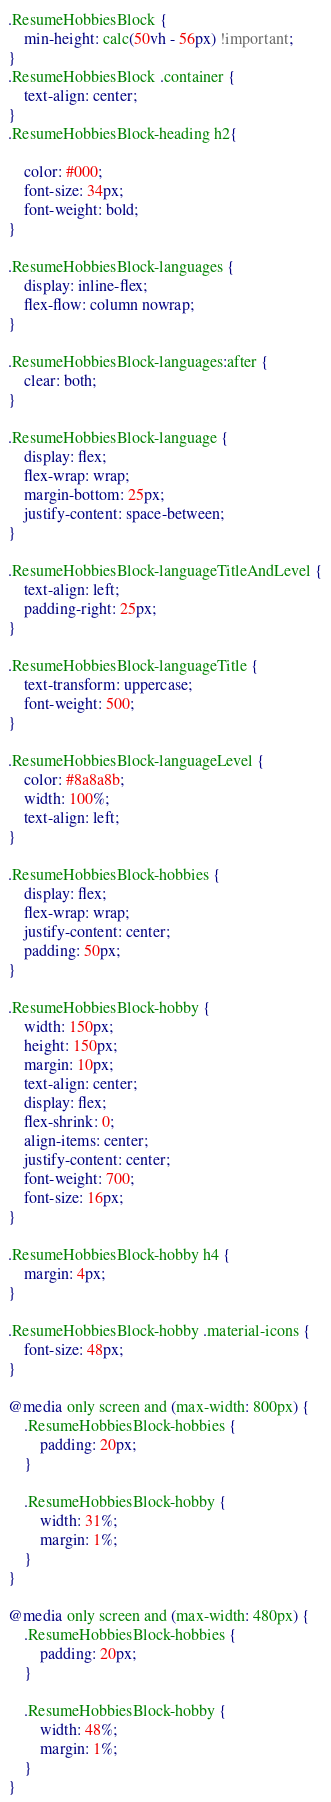<code> <loc_0><loc_0><loc_500><loc_500><_CSS_>.ResumeHobbiesBlock {
    min-height: calc(50vh - 56px) !important;
}
.ResumeHobbiesBlock .container {
    text-align: center;
}
.ResumeHobbiesBlock-heading h2{

    color: #000;
    font-size: 34px;
    font-weight: bold;
}

.ResumeHobbiesBlock-languages {
    display: inline-flex;
    flex-flow: column nowrap;
}

.ResumeHobbiesBlock-languages:after {
    clear: both;
}

.ResumeHobbiesBlock-language {
    display: flex;
    flex-wrap: wrap;
    margin-bottom: 25px;
    justify-content: space-between;
}

.ResumeHobbiesBlock-languageTitleAndLevel {
    text-align: left;
    padding-right: 25px;
}

.ResumeHobbiesBlock-languageTitle {
    text-transform: uppercase;
    font-weight: 500;
}

.ResumeHobbiesBlock-languageLevel {
    color: #8a8a8b;
    width: 100%;
    text-align: left;
}

.ResumeHobbiesBlock-hobbies {
    display: flex;
    flex-wrap: wrap;
    justify-content: center;
    padding: 50px;
}

.ResumeHobbiesBlock-hobby {
    width: 150px;
    height: 150px;
    margin: 10px;
    text-align: center;
    display: flex;
    flex-shrink: 0;
    align-items: center;
    justify-content: center;
    font-weight: 700;
    font-size: 16px;
}

.ResumeHobbiesBlock-hobby h4 {
    margin: 4px;
}

.ResumeHobbiesBlock-hobby .material-icons {
    font-size: 48px;
}

@media only screen and (max-width: 800px) {
    .ResumeHobbiesBlock-hobbies {
        padding: 20px;
    }

    .ResumeHobbiesBlock-hobby {
        width: 31%;
        margin: 1%;
    }
}

@media only screen and (max-width: 480px) {
    .ResumeHobbiesBlock-hobbies {
        padding: 20px;
    }

    .ResumeHobbiesBlock-hobby {
        width: 48%;
        margin: 1%;
    }
}</code> 